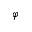Convert formula to latex. <formula><loc_0><loc_0><loc_500><loc_500>\varphi</formula> 